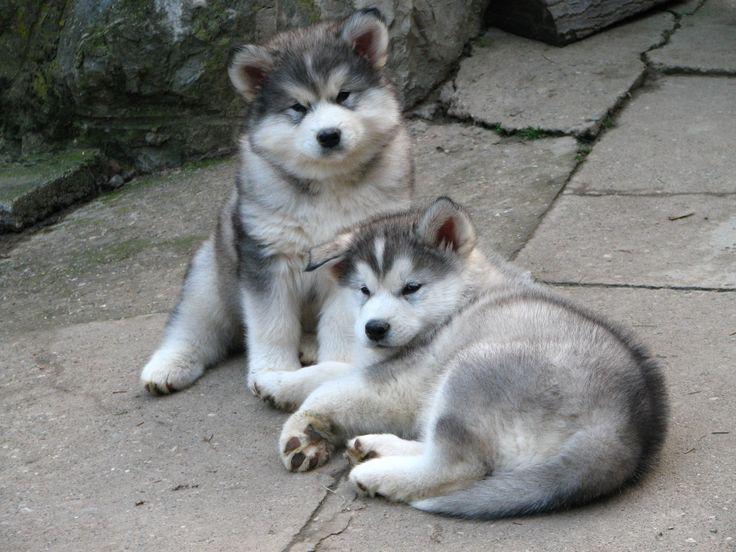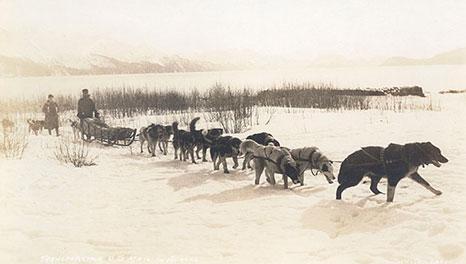The first image is the image on the left, the second image is the image on the right. Analyze the images presented: Is the assertion "The right image contains at least two dogs." valid? Answer yes or no. Yes. 